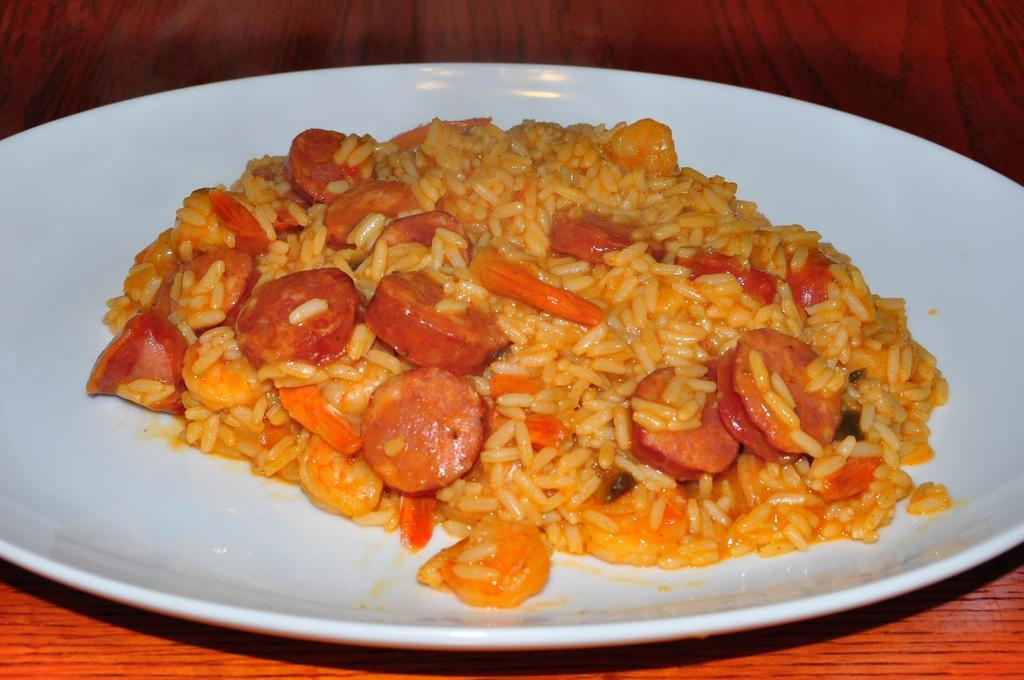What is present on the table in the image? There is food on the table in the image. What type of lace can be seen on the tablecloth in the image? There is no tablecloth or lace present in the image; it only shows food on the table. 